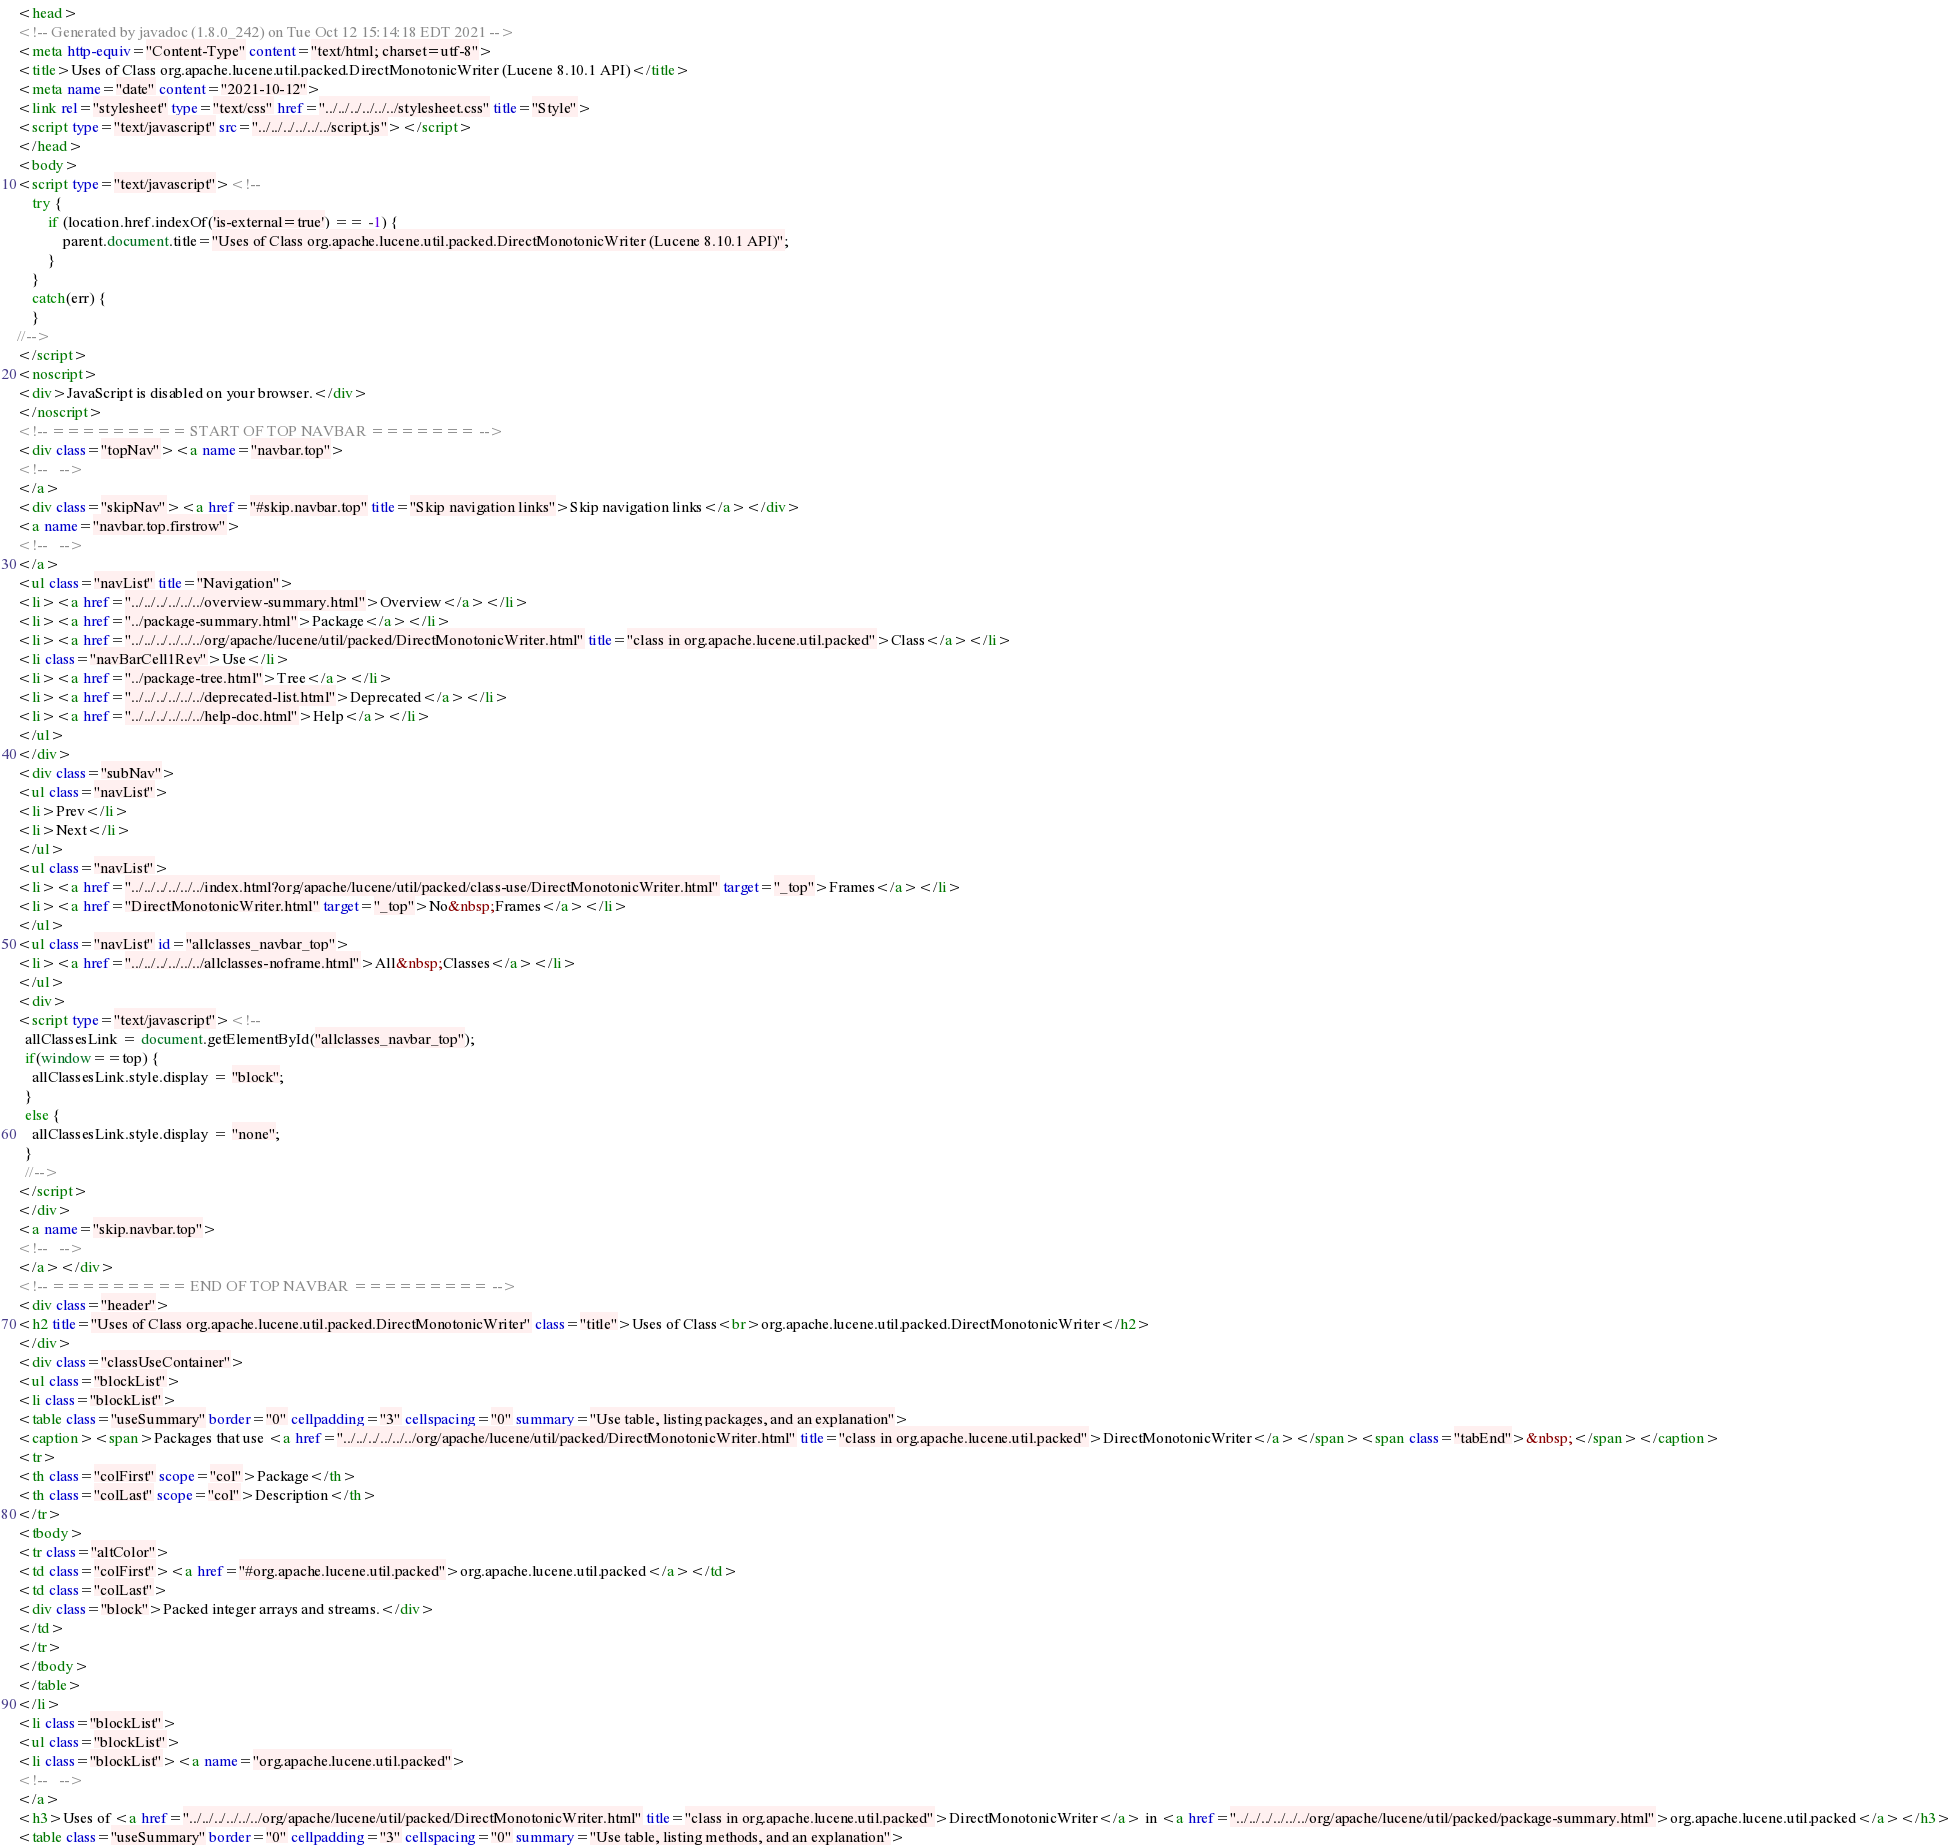<code> <loc_0><loc_0><loc_500><loc_500><_HTML_><head>
<!-- Generated by javadoc (1.8.0_242) on Tue Oct 12 15:14:18 EDT 2021 -->
<meta http-equiv="Content-Type" content="text/html; charset=utf-8">
<title>Uses of Class org.apache.lucene.util.packed.DirectMonotonicWriter (Lucene 8.10.1 API)</title>
<meta name="date" content="2021-10-12">
<link rel="stylesheet" type="text/css" href="../../../../../../stylesheet.css" title="Style">
<script type="text/javascript" src="../../../../../../script.js"></script>
</head>
<body>
<script type="text/javascript"><!--
    try {
        if (location.href.indexOf('is-external=true') == -1) {
            parent.document.title="Uses of Class org.apache.lucene.util.packed.DirectMonotonicWriter (Lucene 8.10.1 API)";
        }
    }
    catch(err) {
    }
//-->
</script>
<noscript>
<div>JavaScript is disabled on your browser.</div>
</noscript>
<!-- ========= START OF TOP NAVBAR ======= -->
<div class="topNav"><a name="navbar.top">
<!--   -->
</a>
<div class="skipNav"><a href="#skip.navbar.top" title="Skip navigation links">Skip navigation links</a></div>
<a name="navbar.top.firstrow">
<!--   -->
</a>
<ul class="navList" title="Navigation">
<li><a href="../../../../../../overview-summary.html">Overview</a></li>
<li><a href="../package-summary.html">Package</a></li>
<li><a href="../../../../../../org/apache/lucene/util/packed/DirectMonotonicWriter.html" title="class in org.apache.lucene.util.packed">Class</a></li>
<li class="navBarCell1Rev">Use</li>
<li><a href="../package-tree.html">Tree</a></li>
<li><a href="../../../../../../deprecated-list.html">Deprecated</a></li>
<li><a href="../../../../../../help-doc.html">Help</a></li>
</ul>
</div>
<div class="subNav">
<ul class="navList">
<li>Prev</li>
<li>Next</li>
</ul>
<ul class="navList">
<li><a href="../../../../../../index.html?org/apache/lucene/util/packed/class-use/DirectMonotonicWriter.html" target="_top">Frames</a></li>
<li><a href="DirectMonotonicWriter.html" target="_top">No&nbsp;Frames</a></li>
</ul>
<ul class="navList" id="allclasses_navbar_top">
<li><a href="../../../../../../allclasses-noframe.html">All&nbsp;Classes</a></li>
</ul>
<div>
<script type="text/javascript"><!--
  allClassesLink = document.getElementById("allclasses_navbar_top");
  if(window==top) {
    allClassesLink.style.display = "block";
  }
  else {
    allClassesLink.style.display = "none";
  }
  //-->
</script>
</div>
<a name="skip.navbar.top">
<!--   -->
</a></div>
<!-- ========= END OF TOP NAVBAR ========= -->
<div class="header">
<h2 title="Uses of Class org.apache.lucene.util.packed.DirectMonotonicWriter" class="title">Uses of Class<br>org.apache.lucene.util.packed.DirectMonotonicWriter</h2>
</div>
<div class="classUseContainer">
<ul class="blockList">
<li class="blockList">
<table class="useSummary" border="0" cellpadding="3" cellspacing="0" summary="Use table, listing packages, and an explanation">
<caption><span>Packages that use <a href="../../../../../../org/apache/lucene/util/packed/DirectMonotonicWriter.html" title="class in org.apache.lucene.util.packed">DirectMonotonicWriter</a></span><span class="tabEnd">&nbsp;</span></caption>
<tr>
<th class="colFirst" scope="col">Package</th>
<th class="colLast" scope="col">Description</th>
</tr>
<tbody>
<tr class="altColor">
<td class="colFirst"><a href="#org.apache.lucene.util.packed">org.apache.lucene.util.packed</a></td>
<td class="colLast">
<div class="block">Packed integer arrays and streams.</div>
</td>
</tr>
</tbody>
</table>
</li>
<li class="blockList">
<ul class="blockList">
<li class="blockList"><a name="org.apache.lucene.util.packed">
<!--   -->
</a>
<h3>Uses of <a href="../../../../../../org/apache/lucene/util/packed/DirectMonotonicWriter.html" title="class in org.apache.lucene.util.packed">DirectMonotonicWriter</a> in <a href="../../../../../../org/apache/lucene/util/packed/package-summary.html">org.apache.lucene.util.packed</a></h3>
<table class="useSummary" border="0" cellpadding="3" cellspacing="0" summary="Use table, listing methods, and an explanation"></code> 